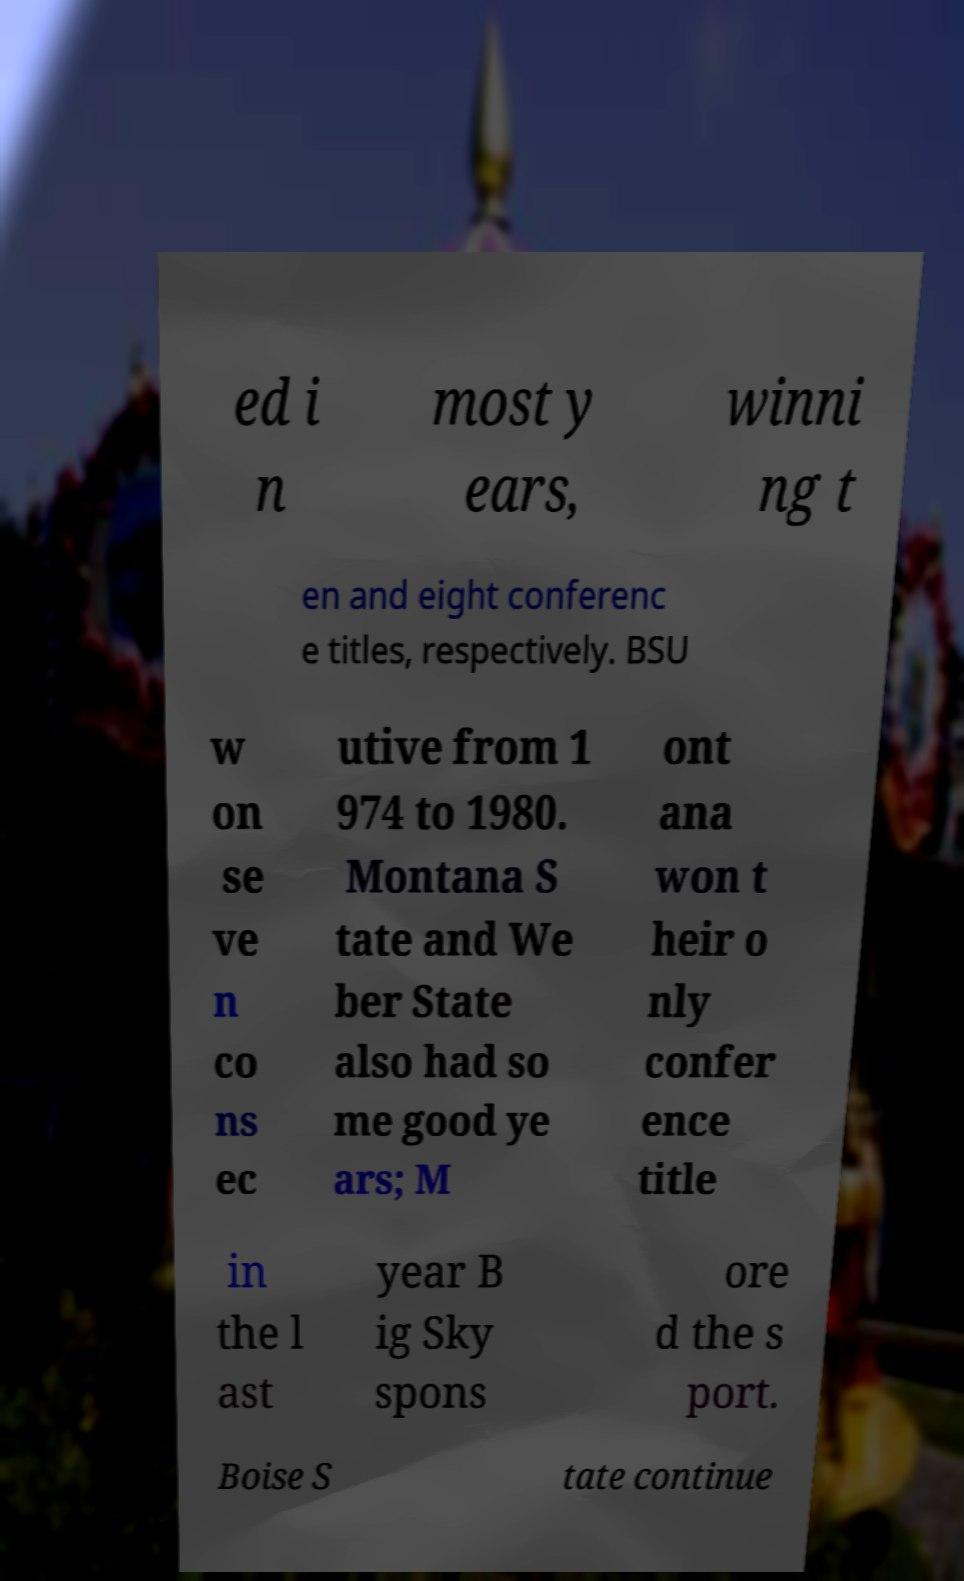Could you assist in decoding the text presented in this image and type it out clearly? ed i n most y ears, winni ng t en and eight conferenc e titles, respectively. BSU w on se ve n co ns ec utive from 1 974 to 1980. Montana S tate and We ber State also had so me good ye ars; M ont ana won t heir o nly confer ence title in the l ast year B ig Sky spons ore d the s port. Boise S tate continue 